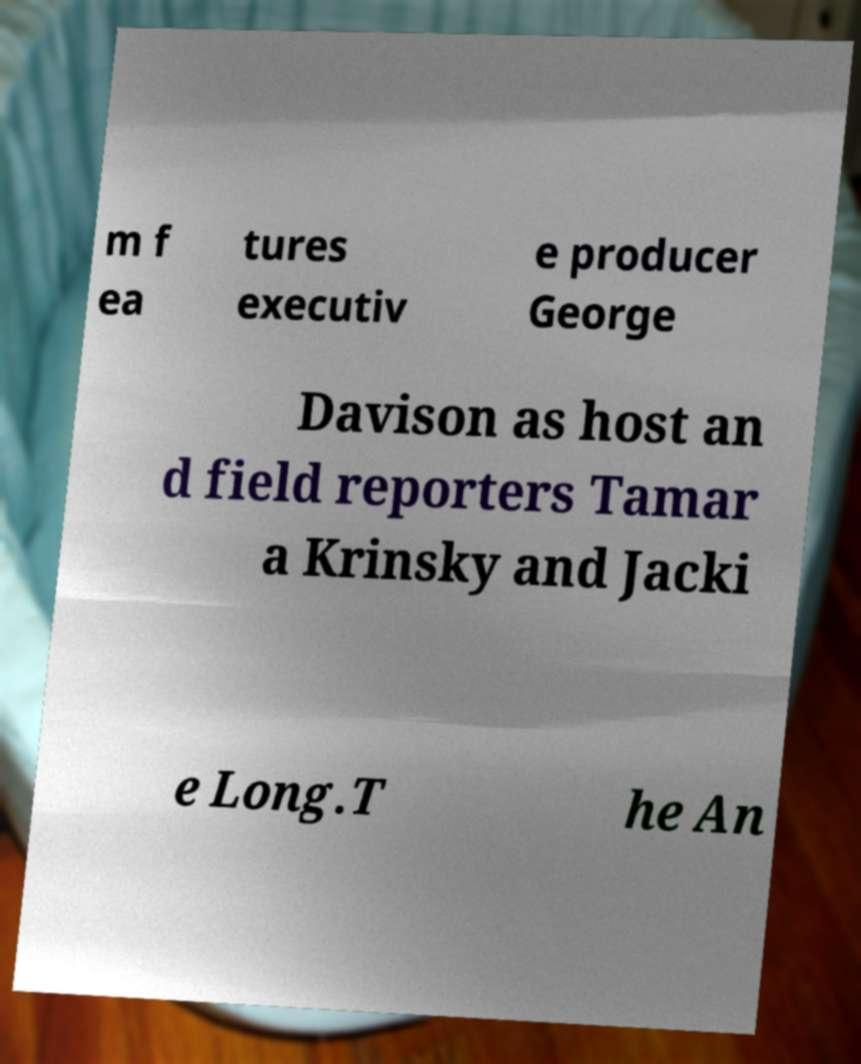Could you assist in decoding the text presented in this image and type it out clearly? m f ea tures executiv e producer George Davison as host an d field reporters Tamar a Krinsky and Jacki e Long.T he An 